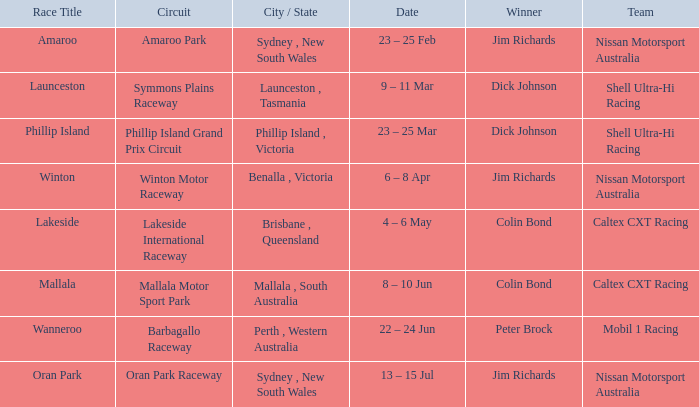Name the team for launceston Shell Ultra-Hi Racing. 